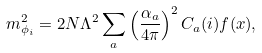Convert formula to latex. <formula><loc_0><loc_0><loc_500><loc_500>m ^ { 2 } _ { \phi _ { i } } = 2 N \Lambda ^ { 2 } \sum _ { a } \left ( \frac { \alpha _ { a } } { 4 \pi } \right ) ^ { 2 } C _ { a } ( i ) f ( x ) ,</formula> 